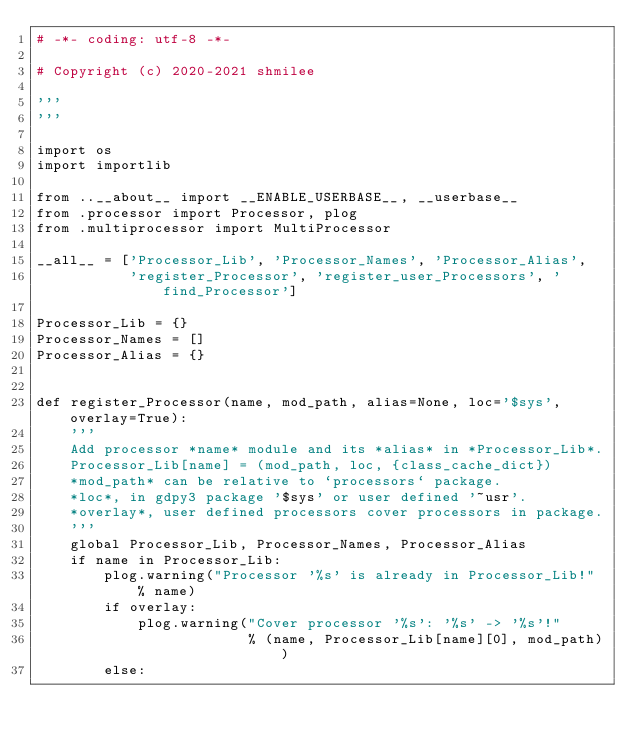Convert code to text. <code><loc_0><loc_0><loc_500><loc_500><_Python_># -*- coding: utf-8 -*-

# Copyright (c) 2020-2021 shmilee

'''
'''

import os
import importlib

from ..__about__ import __ENABLE_USERBASE__, __userbase__
from .processor import Processor, plog
from .multiprocessor import MultiProcessor

__all__ = ['Processor_Lib', 'Processor_Names', 'Processor_Alias',
           'register_Processor', 'register_user_Processors', 'find_Processor']

Processor_Lib = {}
Processor_Names = []
Processor_Alias = {}


def register_Processor(name, mod_path, alias=None, loc='$sys', overlay=True):
    '''
    Add processor *name* module and its *alias* in *Processor_Lib*.
    Processor_Lib[name] = (mod_path, loc, {class_cache_dict})
    *mod_path* can be relative to `processors` package.
    *loc*, in gdpy3 package '$sys' or user defined '~usr'.
    *overlay*, user defined processors cover processors in package.
    '''
    global Processor_Lib, Processor_Names, Processor_Alias
    if name in Processor_Lib:
        plog.warning("Processor '%s' is already in Processor_Lib!" % name)
        if overlay:
            plog.warning("Cover processor '%s': '%s' -> '%s'!"
                         % (name, Processor_Lib[name][0], mod_path))
        else:</code> 